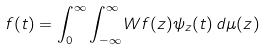<formula> <loc_0><loc_0><loc_500><loc_500>f ( t ) = \int _ { 0 } ^ { \infty } \int _ { - \infty } ^ { \infty } W f ( z ) \psi _ { z } ( t ) \, d \mu ( z )</formula> 